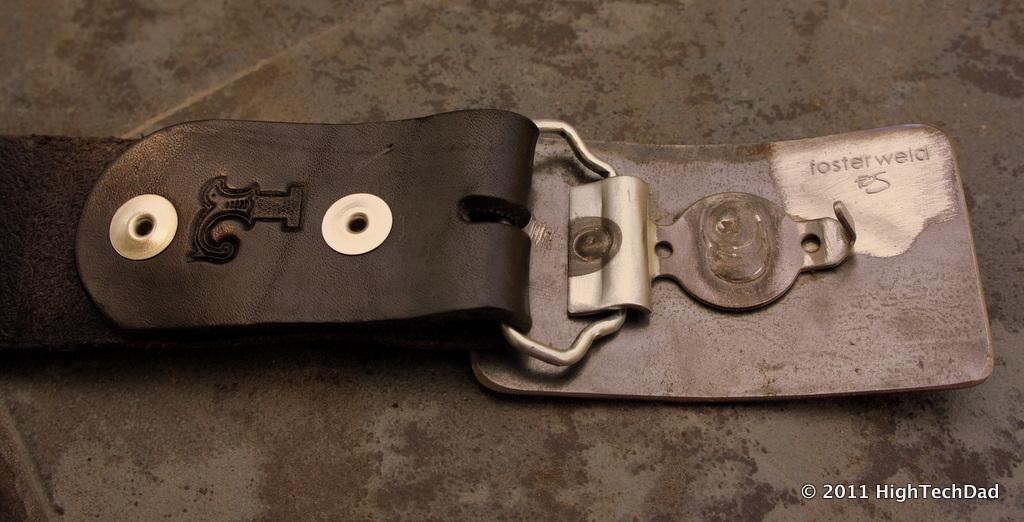What object can be seen in the image? There is a belt in the image. What feature is present on the belt? The belt has a tag. What color is the belt? The belt is black. What type of fasteners are on the belt? The belt has hooks. What material is the belt made of? The belt is made of iron metal. Where is the belt located in the image? The belt is placed on the floor. What type of drink is being served in the image? There is no drink present in the image; it features a belt placed on the floor. What type of crib can be seen in the image? There is no crib present in the image; it features a belt placed on the floor. 